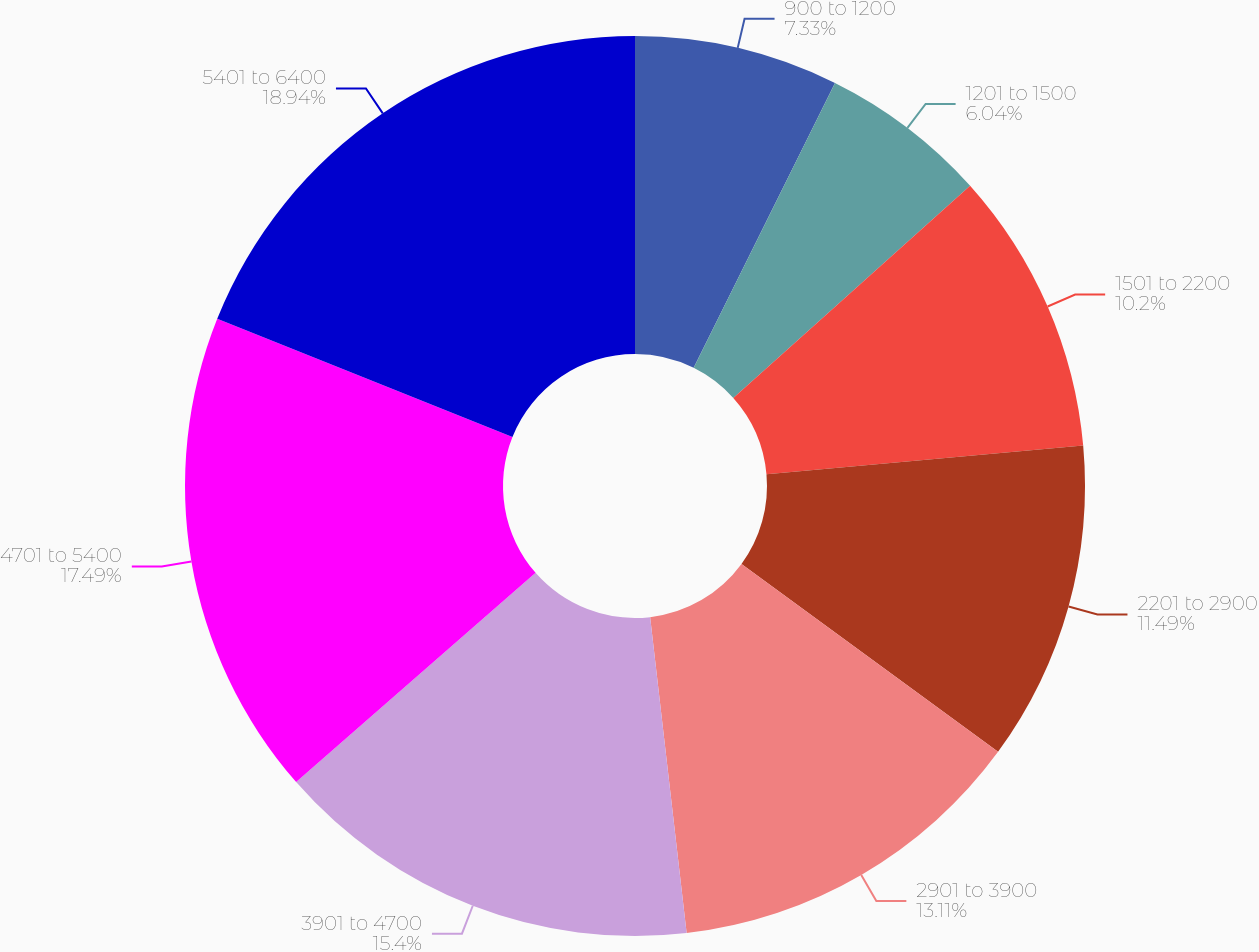<chart> <loc_0><loc_0><loc_500><loc_500><pie_chart><fcel>900 to 1200<fcel>1201 to 1500<fcel>1501 to 2200<fcel>2201 to 2900<fcel>2901 to 3900<fcel>3901 to 4700<fcel>4701 to 5400<fcel>5401 to 6400<nl><fcel>7.33%<fcel>6.04%<fcel>10.2%<fcel>11.49%<fcel>13.11%<fcel>15.4%<fcel>17.49%<fcel>18.94%<nl></chart> 